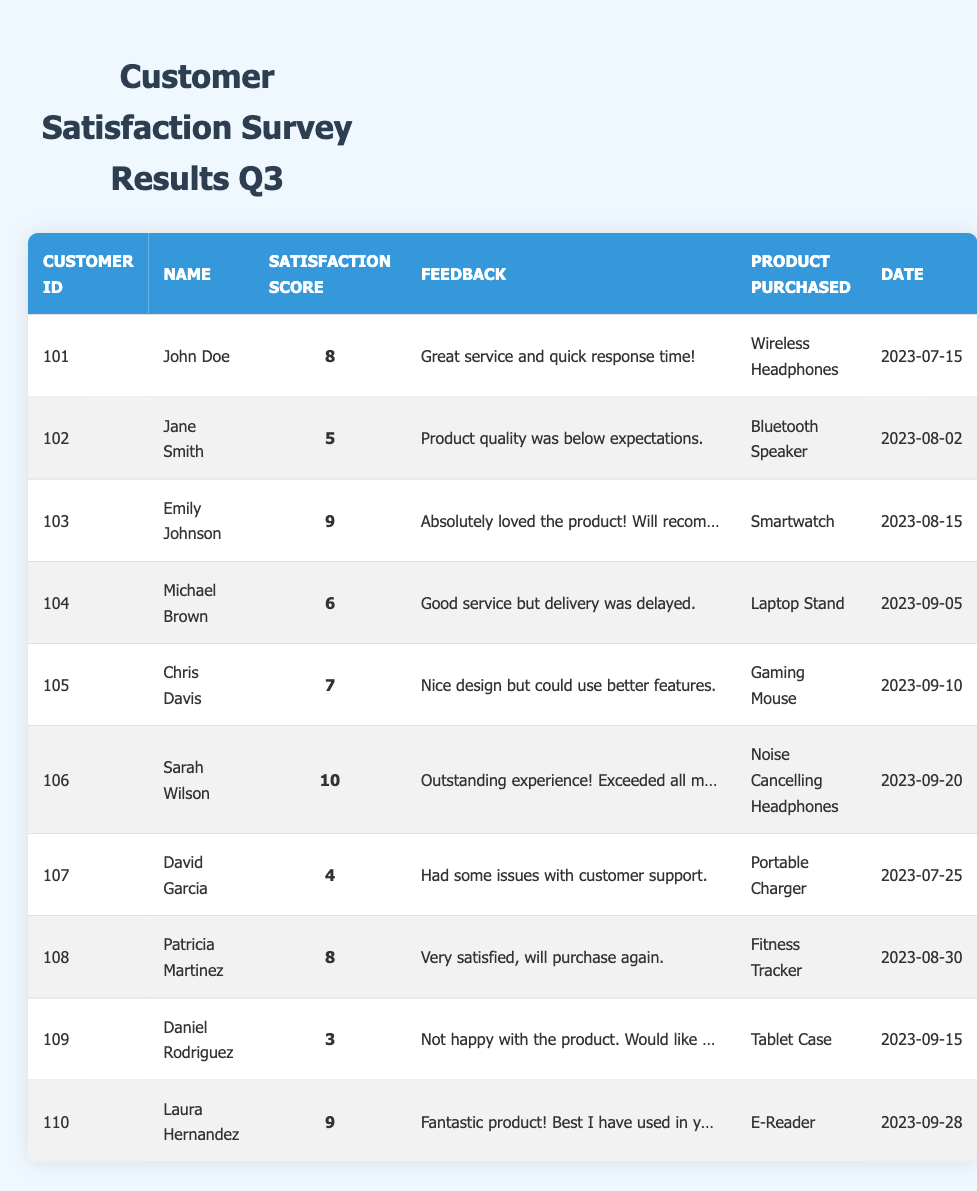What is the satisfaction score of Sarah Wilson? According to the table, Sarah Wilson has a satisfaction score listed as 10.
Answer: 10 Who purchased the Gaming Mouse? The table indicates that Chris Davis purchased the Gaming Mouse.
Answer: Chris Davis What feedback did Michael Brown provide? The feedback provided by Michael Brown is "Good service but delivery was delayed." as shown in the table.
Answer: Good service but delivery was delayed How many customers gave a satisfaction score of 9? The table lists two customers with a satisfaction score of 9: Emily Johnson and Laura Hernandez.
Answer: 2 What is the average satisfaction score for all customers? To find the average, we add the satisfaction scores (8 + 5 + 9 + 6 + 7 + 10 + 4 + 8 + 3 + 9) = 69, and then divide by the number of customers (10), giving us an average of 69 / 10 = 6.9.
Answer: 6.9 Did any customer report wanting a refund? Yes, according to the table, Daniel Rodriguez expressed that he is "Not happy with the product. Would like a refund."
Answer: Yes Which product had the highest satisfaction score? The table shows that the product with the highest satisfaction score (10) is the Noise Cancelling Headphones, purchased by Sarah Wilson.
Answer: Noise Cancelling Headphones What was the feedback from the customer with the lowest satisfaction score? The lowest satisfaction score is 3, given by Daniel Rodriguez, whose feedback states, "Not happy with the product. Would like a refund."
Answer: Not happy with the product. Would like a refund How many customers were satisfied with their products (score 7 or higher)? The following customers scored 7 or higher: John Doe, Emily Johnson, Sarah Wilson, Patricia Martinez, and Laura Hernandez. This means 5 customers were satisfied.
Answer: 5 What is the satisfaction score difference between Sarah Wilson and David Garcia? Sarah Wilson has a score of 10 and David Garcia has a score of 4. Subtracting these gives 10 - 4 = 6, which is the difference.
Answer: 6 